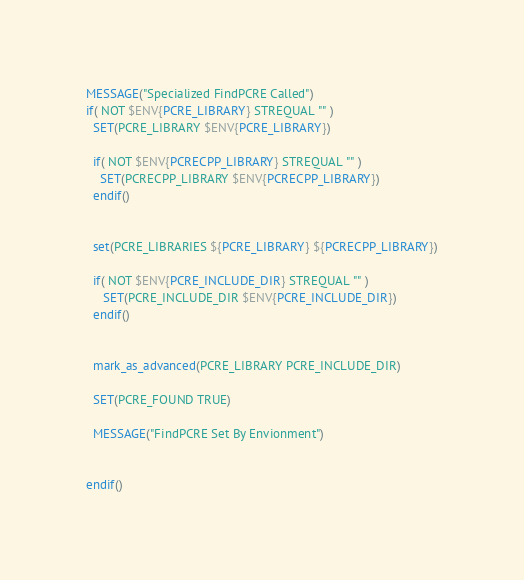<code> <loc_0><loc_0><loc_500><loc_500><_CMake_>MESSAGE("Specialized FindPCRE Called")
if( NOT $ENV{PCRE_LIBRARY} STREQUAL "" )
  SET(PCRE_LIBRARY $ENV{PCRE_LIBRARY})

  if( NOT $ENV{PCRECPP_LIBRARY} STREQUAL "" )
  	SET(PCRECPP_LIBRARY $ENV{PCRECPP_LIBRARY})
  endif()


  set(PCRE_LIBRARIES ${PCRE_LIBRARY} ${PCRECPP_LIBRARY})

  if( NOT $ENV{PCRE_INCLUDE_DIR} STREQUAL "" )
     SET(PCRE_INCLUDE_DIR $ENV{PCRE_INCLUDE_DIR})
  endif()


  mark_as_advanced(PCRE_LIBRARY PCRE_INCLUDE_DIR)

  SET(PCRE_FOUND TRUE)

  MESSAGE("FindPCRE Set By Envionment")


endif()</code> 